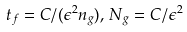Convert formula to latex. <formula><loc_0><loc_0><loc_500><loc_500>t _ { f } = C / ( \epsilon ^ { 2 } n _ { g } ) , \, N _ { g } = C / \epsilon ^ { 2 }</formula> 